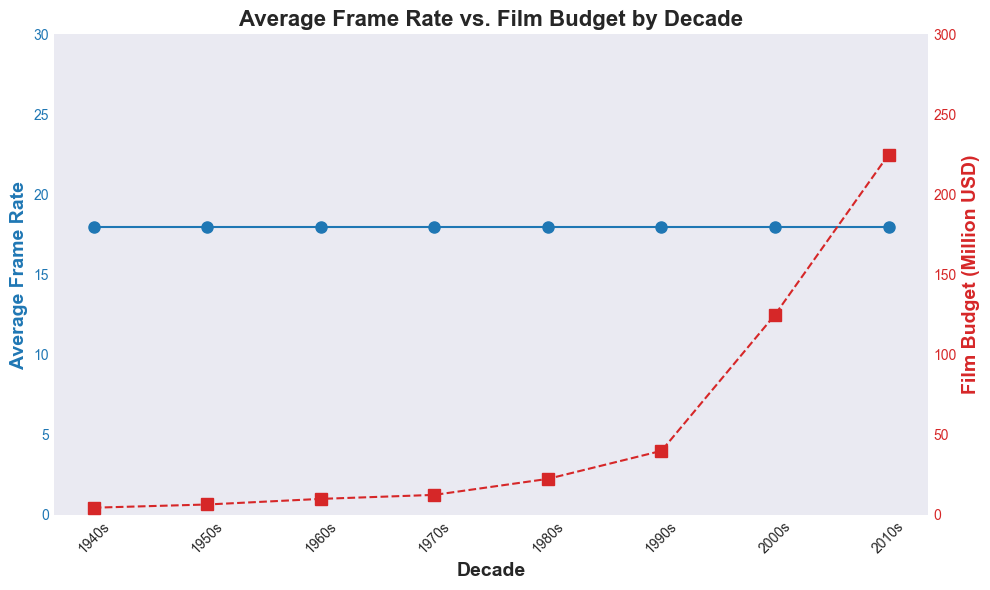What is the trend of the average frame rate from the 1940s to the 2010s? The average frame rate stays constant at either 12 or 24 frames per second across all the decades from the 1940s to the 2010s.
Answer: Constant How does the film budget change from the 1940s to the 2010s? The film budget shows an increasing trend, starting from $3-6 million in the 1940s and reaching $200-250 million in the 2010s. It increments at almost every decade.
Answer: Increases What decade had the largest difference in film budget between the films with 12 and 24 frame rates? In the 2010s, the film with a 12 fps frame rate had a budget of $200 million, and the film with a 24 fps frame rate had a budget of $250 million, making the difference $50 million.
Answer: 2010s Which decade showed the highest film budget for a film with a 12 frame rate? By looking at each decade, the 2010s had the highest budget for a film with a 12 frame rate at $200 million.
Answer: 2010s Which decade showed the lowest film budget for a film with a 24 frame rate? In the 1940s, the lowest budget for a film with a 24 frame rate was $6 million.
Answer: 1940s Considering films with an average frame rate of 12, how much did the budget increase from the 1940s to the 2010s? The budget increased from $3 million in the 1940s to $200 million in the 2010s, which is an increase of $197 million.
Answer: $197 million In the 1980s, how much higher is the budget for films with 24 frame rates compared to those with 12 frame rates? In the 1980s, the film with a 12 frame rate had a budget of $20 million, while the film with a 24 frame rate had a budget of $25 million, making the difference $5 million.
Answer: $5 million In which decade did the average film budget most significantly increase compared to the previous decade? The most significant increase in the average film budget (for both frame rates) occurred from the 1980s to the 1990s, where the budget jumped significantly from $20-$25 million to $30-$50 million for films with 12 and 24 frame rates, respectively.
Answer: 1990s 